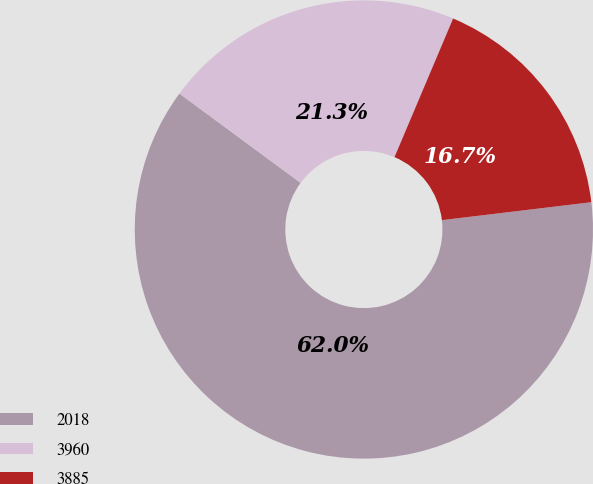Convert chart to OTSL. <chart><loc_0><loc_0><loc_500><loc_500><pie_chart><fcel>2018<fcel>3960<fcel>3885<nl><fcel>62.01%<fcel>21.26%<fcel>16.73%<nl></chart> 